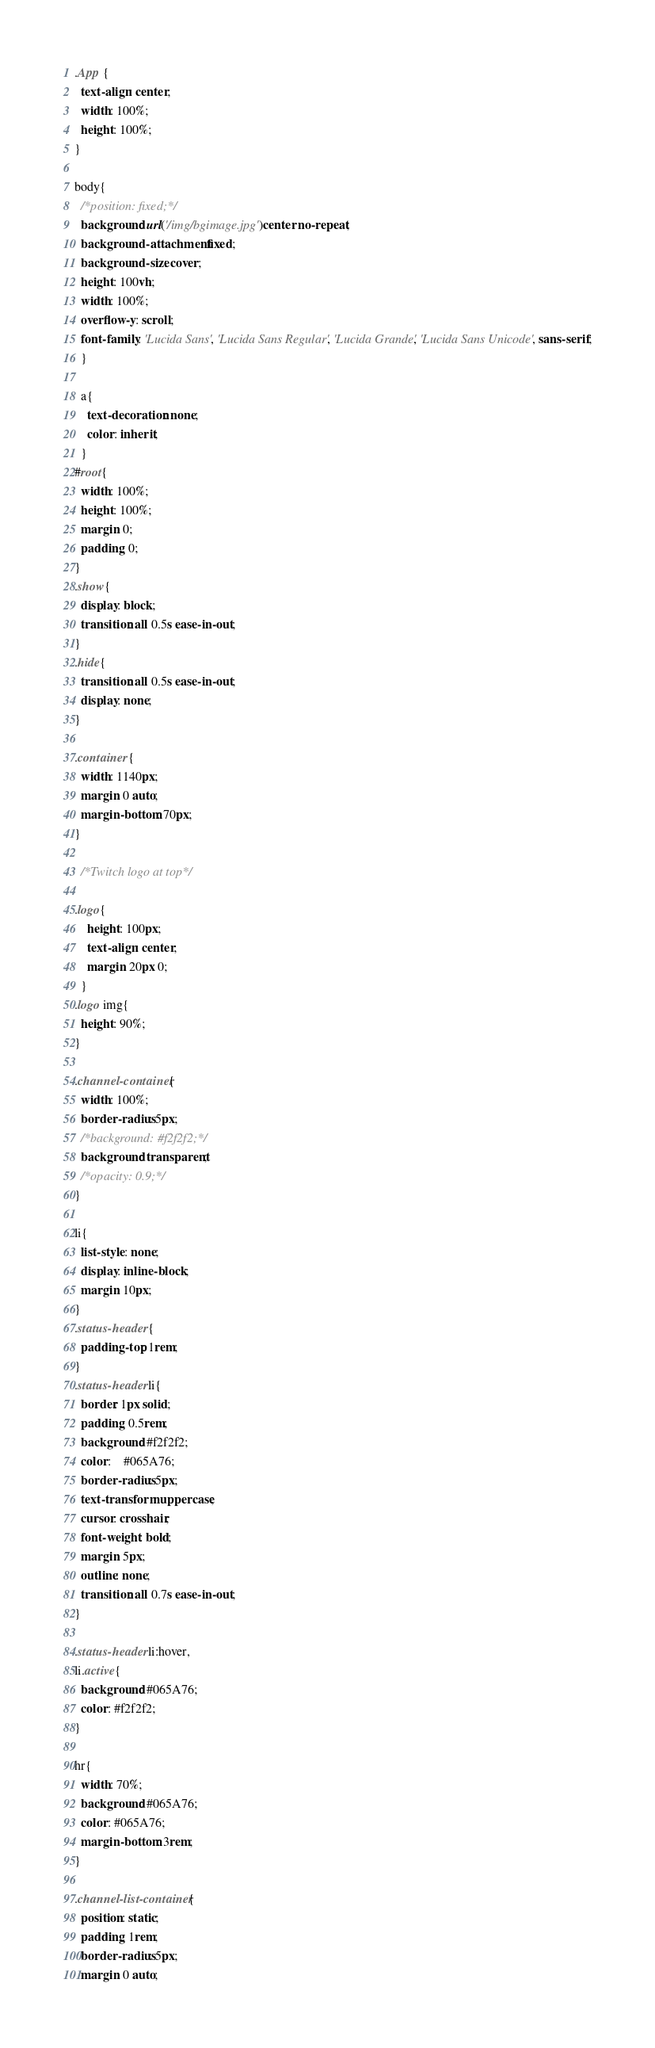<code> <loc_0><loc_0><loc_500><loc_500><_CSS_>.App {
  text-align: center;
  width: 100%;
  height: 100%;
}

body{
  /*position: fixed;*/
  background: url('/img/bgimage.jpg')center no-repeat;
  background-attachment: fixed;
  background-size: cover;
  height: 100vh;
  width: 100%;
  overflow-y: scroll;
  font-family: 'Lucida Sans', 'Lucida Sans Regular', 'Lucida Grande', 'Lucida Sans Unicode', sans-serif;
  }

  a{
    text-decoration: none;
    color: inherit;
  }
#root{
  width: 100%;
  height: 100%;
  margin: 0;
  padding: 0;
}
.show{
  display: block;
  transition: all 0.5s ease-in-out;
}
.hide{
  transition: all 0.5s ease-in-out;
  display: none;
}

.container {
  width: 1140px;
  margin: 0 auto;
  margin-bottom: 70px;
}

  /*Twitch logo at top*/

.logo{
    height: 100px;
    text-align: center;
    margin: 20px 0;
  }
.logo img{
  height: 90%;
}

.channel-container{
  width: 100%;
  border-radius: 5px;
  /*background: #f2f2f2;*/
  background: transparent;
  /*opacity: 0.9;*/
}

li{
  list-style: none;
  display: inline-block;
  margin: 10px;
}
.status-header {
  padding-top: 1rem;
}
.status-header li{
  border: 1px solid;
  padding: 0.5rem;
  background: #f2f2f2;
  color: 	#065A76;
  border-radius: 5px;
  text-transform: uppercase;
  cursor: crosshair;
  font-weight: bold;
  margin: 5px;
  outline: none;
  transition: all 0.7s ease-in-out;
}

.status-header li:hover,
li.active{
  background: #065A76;
  color: #f2f2f2;
}

hr{
  width: 70%;
  background: #065A76;
  color: #065A76;
  margin-bottom: 3rem;
}

.channel-list-container{
  position: static;
  padding: 1rem;
  border-radius: 5px;
  margin: 0 auto;</code> 